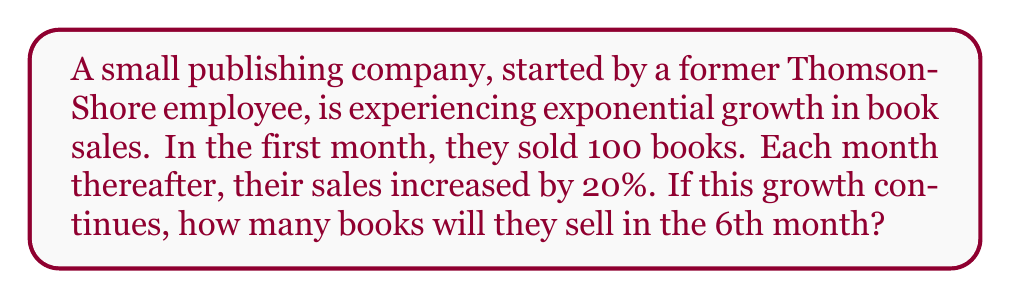Can you answer this question? Let's approach this step-by-step:

1) This is a geometric sequence with:
   - First term: $a_1 = 100$
   - Common ratio: $r = 1 + 20\% = 1.2$

2) The general term of a geometric sequence is given by:
   $$a_n = a_1 \cdot r^{n-1}$$

3) We want to find the 6th term, so $n = 6$:
   $$a_6 = 100 \cdot (1.2)^{6-1} = 100 \cdot (1.2)^5$$

4) Let's calculate this:
   $$\begin{align}
   a_6 &= 100 \cdot (1.2)^5 \\
   &= 100 \cdot 2.4883 \\
   &= 248.83
   \end{align}$$

5) Since we can't sell fractional books, we round to the nearest whole number:
   $$a_6 \approx 249$$

Therefore, in the 6th month, the company will sell approximately 249 books.
Answer: 249 books 